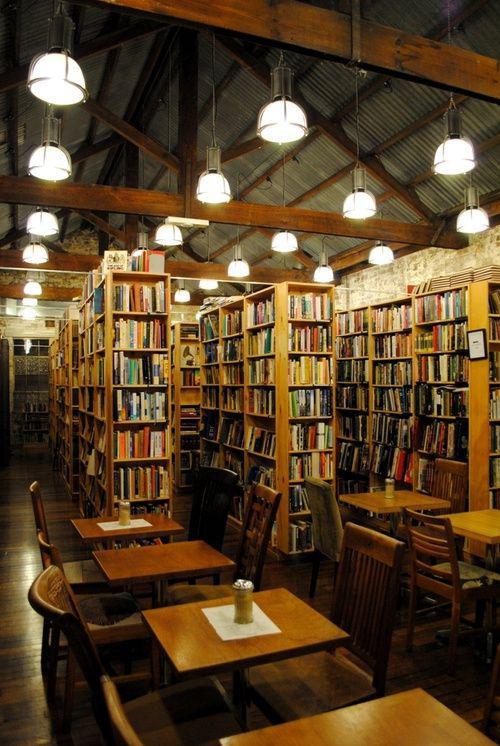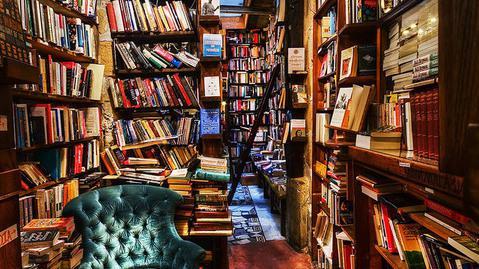The first image is the image on the left, the second image is the image on the right. Examine the images to the left and right. Is the description "There is only an image of the inside of a bookstore." accurate? Answer yes or no. Yes. The first image is the image on the left, the second image is the image on the right. Assess this claim about the two images: "To the left, there are some chairs that people can use for sitting.". Correct or not? Answer yes or no. Yes. 